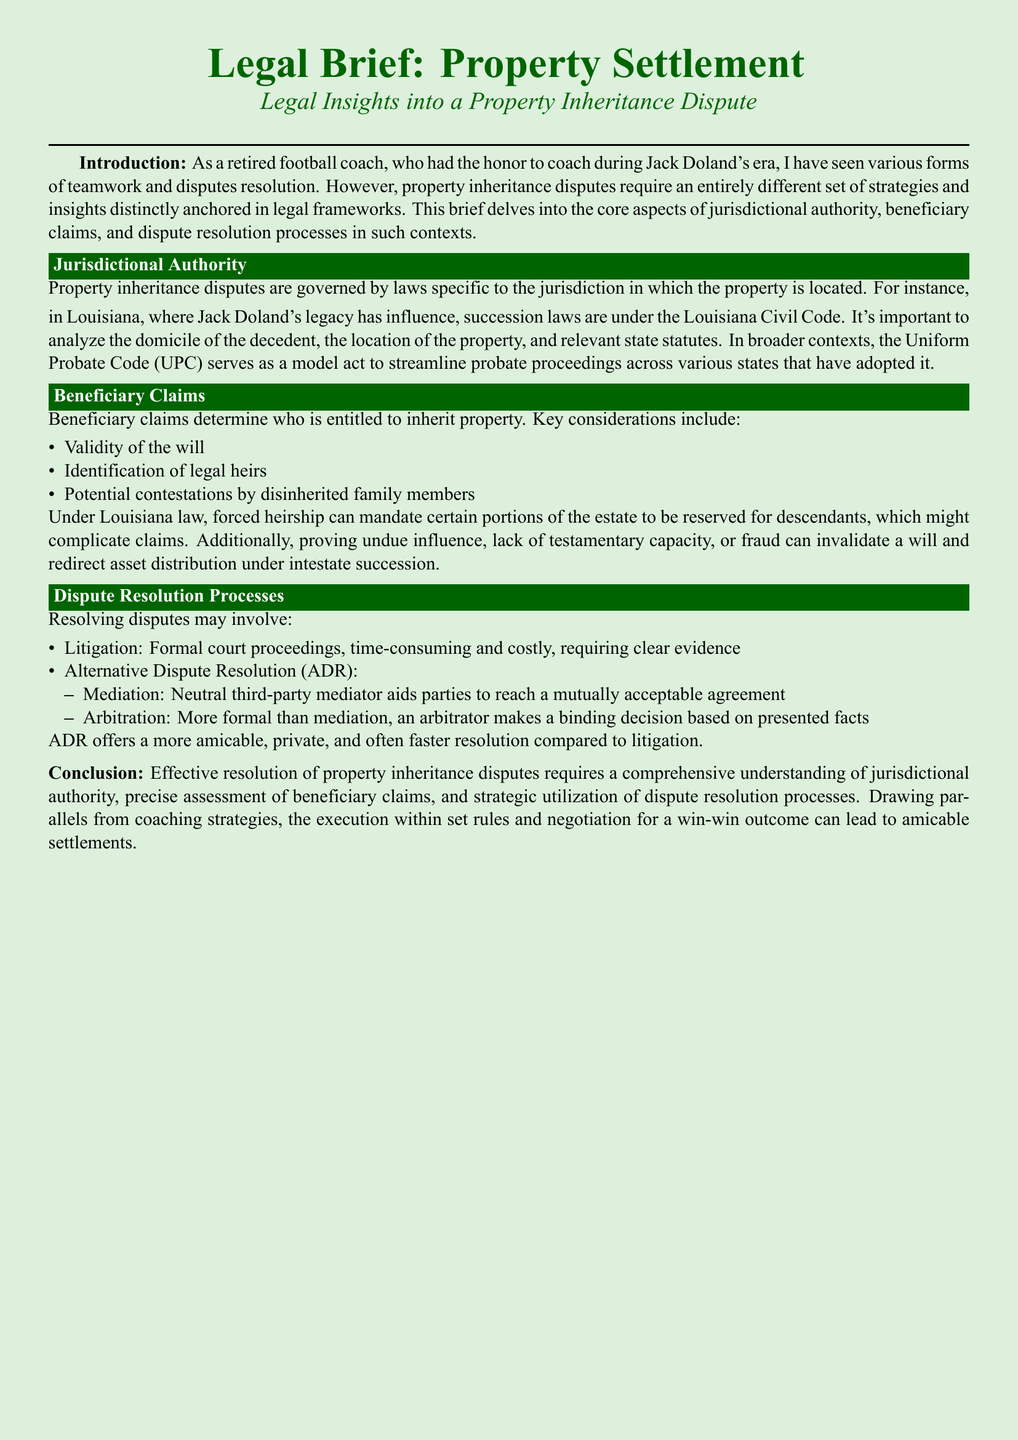what governs property inheritance disputes? The document states that property inheritance disputes are governed by laws specific to the jurisdiction in which the property is located.
Answer: laws specific to the jurisdiction what code serves as a model act for probate proceedings? The Uniform Probate Code serves as a model act to streamline probate proceedings across various states.
Answer: Uniform Probate Code what is one consideration for beneficiary claims? The document lists several key considerations for beneficiary claims, including validity of the will.
Answer: validity of the will what can invalidate a will according to the document? The document mentions that proving undue influence can invalidate a will.
Answer: undue influence what is one method of dispute resolution mentioned? The document outlines several dispute resolution processes, one of which is mediation.
Answer: mediation how does ADR compare to litigation? The document notes that ADR offers a more amicable, private, and often faster resolution compared to litigation.
Answer: more amicable, private, and faster what is the importance of jurisdictional authority in property disputes? The document indicates that it is important to analyze the domicile of the decedent and the location of the property.
Answer: domicile of the decedent and location of the property what type of legal proceedings can property disputes involve? The document states that resolving disputes may involve litigation.
Answer: litigation 